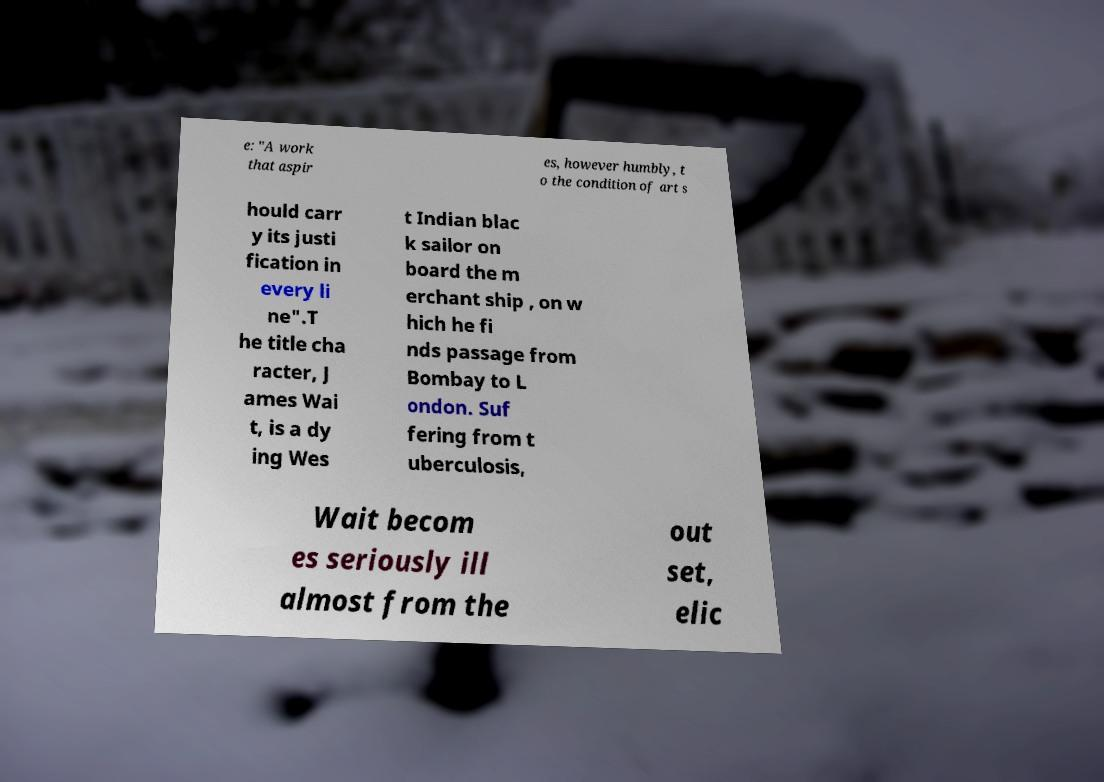Could you assist in decoding the text presented in this image and type it out clearly? e: "A work that aspir es, however humbly, t o the condition of art s hould carr y its justi fication in every li ne".T he title cha racter, J ames Wai t, is a dy ing Wes t Indian blac k sailor on board the m erchant ship , on w hich he fi nds passage from Bombay to L ondon. Suf fering from t uberculosis, Wait becom es seriously ill almost from the out set, elic 